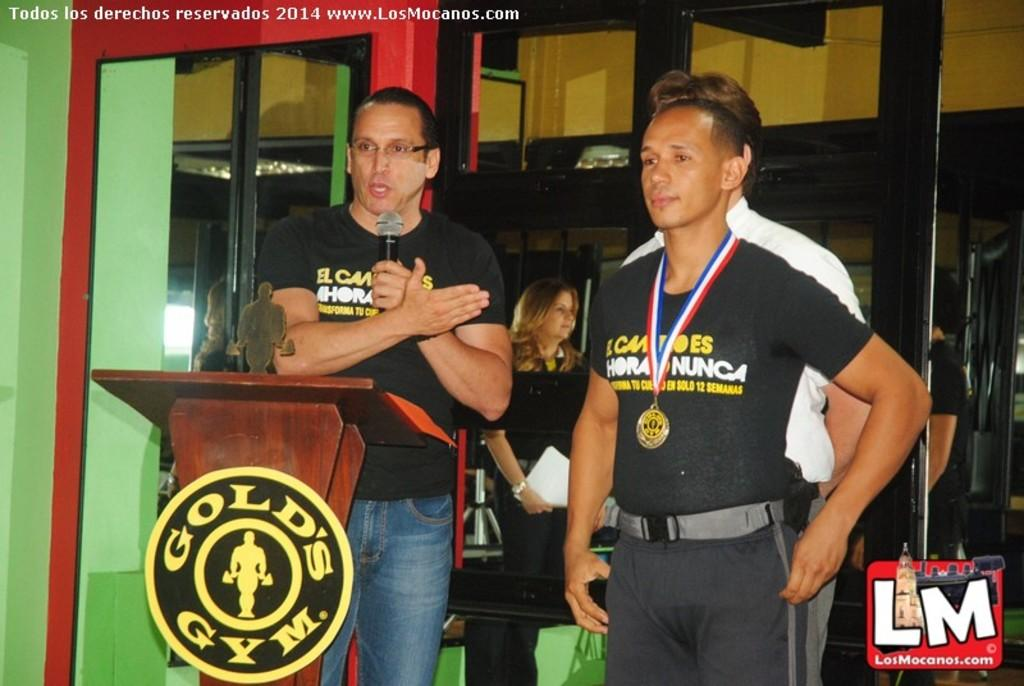<image>
Describe the image concisely. Two men in a black shirts stand behind a podium that says Gold's Gym. 